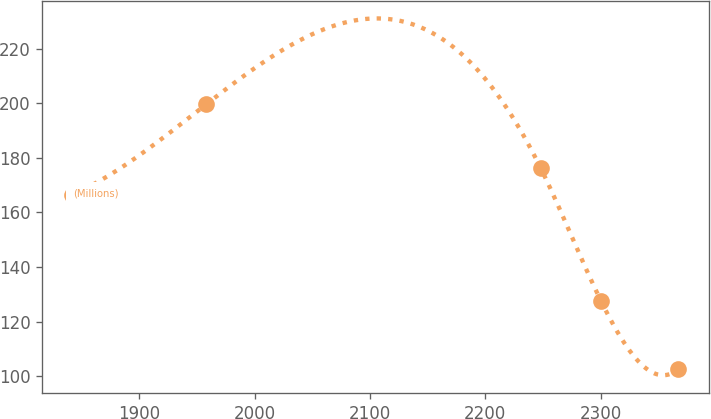Convert chart to OTSL. <chart><loc_0><loc_0><loc_500><loc_500><line_chart><ecel><fcel>(Millions)<nl><fcel>1842.1<fcel>166.52<nl><fcel>1958.15<fcel>199.58<nl><fcel>2247.97<fcel>176.23<nl><fcel>2300.49<fcel>127.36<nl><fcel>2367.3<fcel>102.51<nl></chart> 